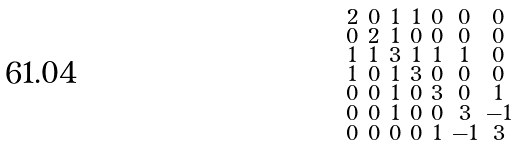<formula> <loc_0><loc_0><loc_500><loc_500>\begin{smallmatrix} 2 & 0 & 1 & 1 & 0 & 0 & 0 \\ 0 & 2 & 1 & 0 & 0 & 0 & 0 \\ 1 & 1 & 3 & 1 & 1 & 1 & 0 \\ 1 & 0 & 1 & 3 & 0 & 0 & 0 \\ 0 & 0 & 1 & 0 & 3 & 0 & 1 \\ 0 & 0 & 1 & 0 & 0 & 3 & - 1 \\ 0 & 0 & 0 & 0 & 1 & - 1 & 3 \end{smallmatrix}</formula> 